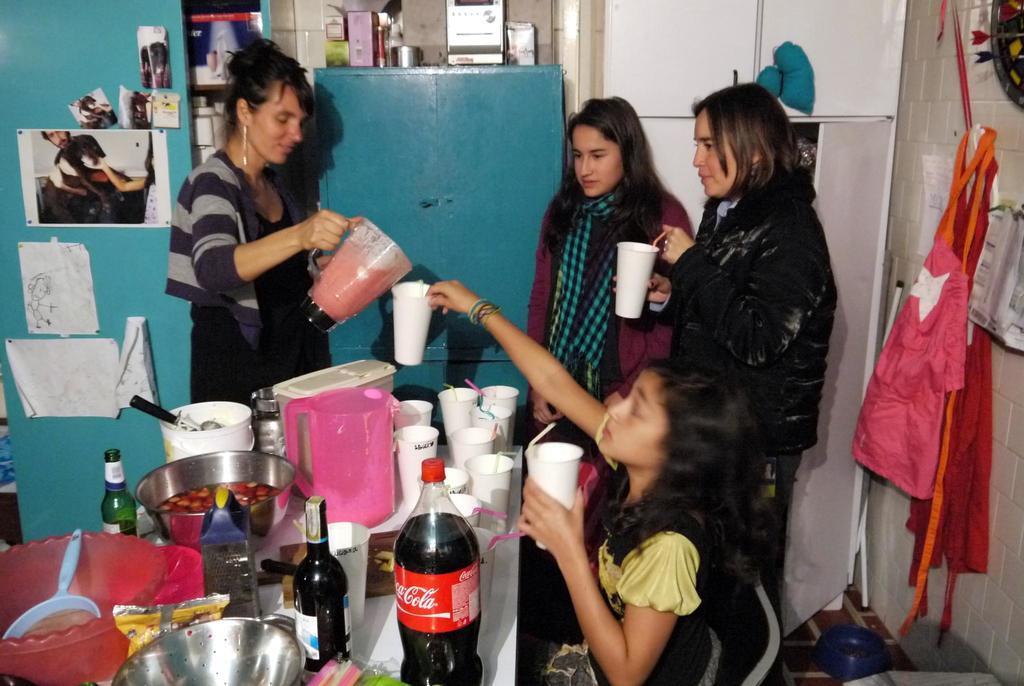In one or two sentences, can you explain what this image depicts? In this image there are group of persons having their drinks and at the left side of the image there are bottles and food items on the table and at the top left of the image there are paintings attached to the wall. 